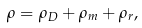<formula> <loc_0><loc_0><loc_500><loc_500>\rho = \rho _ { D } + \rho _ { m } + \rho _ { r } ,</formula> 